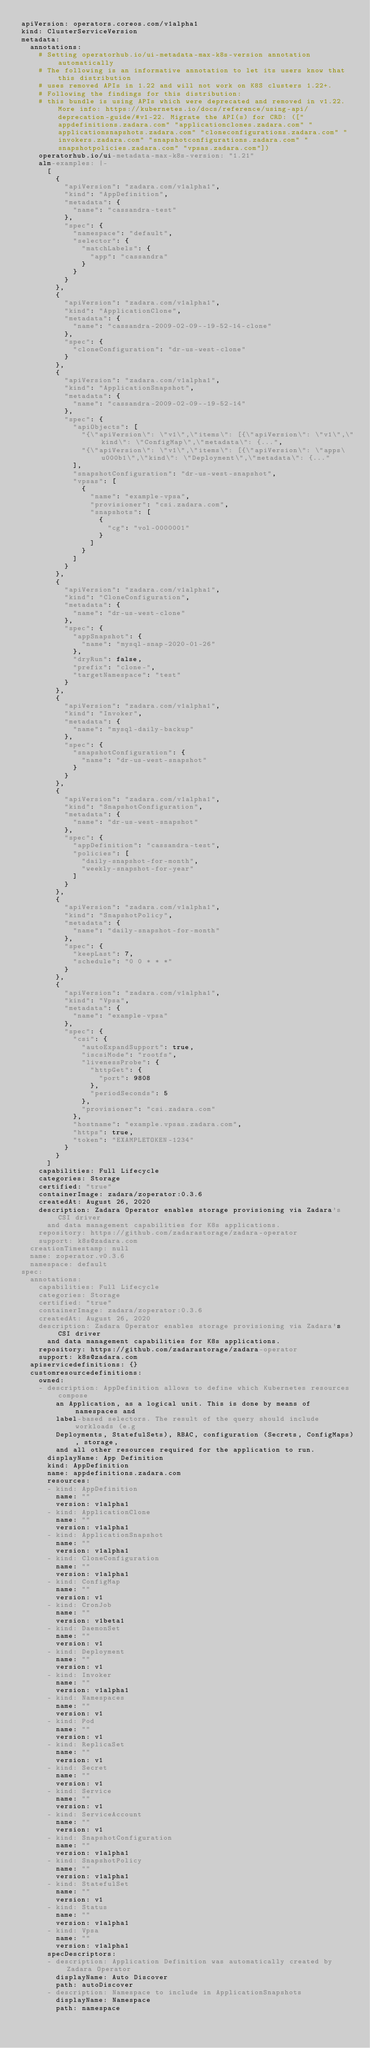<code> <loc_0><loc_0><loc_500><loc_500><_YAML_>apiVersion: operators.coreos.com/v1alpha1
kind: ClusterServiceVersion
metadata:
  annotations:
    # Setting operatorhub.io/ui-metadata-max-k8s-version annotation automatically
    # The following is an informative annotation to let its users know that this distribution
    # uses removed APIs in 1.22 and will not work on K8S clusters 1.22+.
    # Following the findings for this distribution:
    # this bundle is using APIs which were deprecated and removed in v1.22. More info: https://kubernetes.io/docs/reference/using-api/deprecation-guide/#v1-22. Migrate the API(s) for CRD: (["appdefinitions.zadara.com" "applicationclones.zadara.com" "applicationsnapshots.zadara.com" "cloneconfigurations.zadara.com" "invokers.zadara.com" "snapshotconfigurations.zadara.com" "snapshotpolicies.zadara.com" "vpsas.zadara.com"])
    operatorhub.io/ui-metadata-max-k8s-version: "1.21"
    alm-examples: |-
      [
        {
          "apiVersion": "zadara.com/v1alpha1",
          "kind": "AppDefinition",
          "metadata": {
            "name": "cassandra-test"
          },
          "spec": {
            "namespace": "default",
            "selector": {
              "matchLabels": {
                "app": "cassandra"
              }
            }
          }
        },
        {
          "apiVersion": "zadara.com/v1alpha1",
          "kind": "ApplicationClone",
          "metadata": {
            "name": "cassandra-2009-02-09--19-52-14-clone"
          },
          "spec": {
            "cloneConfiguration": "dr-us-west-clone"
          }
        },
        {
          "apiVersion": "zadara.com/v1alpha1",
          "kind": "ApplicationSnapshot",
          "metadata": {
            "name": "cassandra-2009-02-09--19-52-14"
          },
          "spec": {
            "apiObjects": [
              "{\"apiVersion\": \"v1\",\"items\": [{\"apiVersion\": \"v1\",\"kind\": \"ConfigMap\",\"metadata\": {...",
              "{\"apiVersion\": \"v1\",\"items\": [{\"apiVersion\": \"apps\u000b1\",\"kind\": \"Deployment\",\"metadata\": {..."
            ],
            "snapshotConfiguration": "dr-us-west-snapshot",
            "vpsas": [
              {
                "name": "example-vpsa",
                "provisioner": "csi.zadara.com",
                "snapshots": [
                  {
                    "cg": "vol-0000001"
                  }
                ]
              }
            ]
          }
        },
        {
          "apiVersion": "zadara.com/v1alpha1",
          "kind": "CloneConfiguration",
          "metadata": {
            "name": "dr-us-west-clone"
          },
          "spec": {
            "appSnapshot": {
              "name": "mysql-snap-2020-01-26"
            },
            "dryRun": false,
            "prefix": "clone-",
            "targetNamespace": "test"
          }
        },
        {
          "apiVersion": "zadara.com/v1alpha1",
          "kind": "Invoker",
          "metadata": {
            "name": "mysql-daily-backup"
          },
          "spec": {
            "snapshotConfiguration": {
              "name": "dr-us-west-snapshot"
            }
          }
        },
        {
          "apiVersion": "zadara.com/v1alpha1",
          "kind": "SnapshotConfiguration",
          "metadata": {
            "name": "dr-us-west-snapshot"
          },
          "spec": {
            "appDefinition": "cassandra-test",
            "policies": [
              "daily-snapshot-for-month",
              "weekly-snapshot-for-year"
            ]
          }
        },
        {
          "apiVersion": "zadara.com/v1alpha1",
          "kind": "SnapshotPolicy",
          "metadata": {
            "name": "daily-snapshot-for-month"
          },
          "spec": {
            "keepLast": 7,
            "schedule": "0 0 * * *"
          }
        },
        {
          "apiVersion": "zadara.com/v1alpha1",
          "kind": "Vpsa",
          "metadata": {
            "name": "example-vpsa"
          },
          "spec": {
            "csi": {
              "autoExpandSupport": true,
              "iscsiMode": "rootfs",
              "livenessProbe": {
                "httpGet": {
                  "port": 9808
                },
                "periodSeconds": 5
              },
              "provisioner": "csi.zadara.com"
            },
            "hostname": "example.vpsas.zadara.com",
            "https": true,
            "token": "EXAMPLETOKEN-1234"
          }
        }
      ]
    capabilities: Full Lifecycle
    categories: Storage
    certified: "true"
    containerImage: zadara/zoperator:0.3.6
    createdAt: August 26, 2020
    description: Zadara Operator enables storage provisioning via Zadara's CSI driver
      and data management capabilities for K8s applications.
    repository: https://github.com/zadarastorage/zadara-operator
    support: k8s@zadara.com
  creationTimestamp: null
  name: zoperator.v0.3.6
  namespace: default
spec:
  annotations:
    capabilities: Full Lifecycle
    categories: Storage
    certified: "true"
    containerImage: zadara/zoperator:0.3.6
    createdAt: August 26, 2020
    description: Zadara Operator enables storage provisioning via Zadara's CSI driver
      and data management capabilities for K8s applications.
    repository: https://github.com/zadarastorage/zadara-operator
    support: k8s@zadara.com
  apiservicedefinitions: {}
  customresourcedefinitions:
    owned:
    - description: AppDefinition allows to define which Kubernetes resources compose
        an Application, as a logical unit. This is done by means of namespaces and
        label-based selectors. The result of the query should include workloads (e.g
        Deployments, StatefulSets), RBAC, configuration (Secrets, ConfigMaps), storage,
        and all other resources required for the application to run.
      displayName: App Definition
      kind: AppDefinition
      name: appdefinitions.zadara.com
      resources:
      - kind: AppDefinition
        name: ""
        version: v1alpha1
      - kind: ApplicationClone
        name: ""
        version: v1alpha1
      - kind: ApplicationSnapshot
        name: ""
        version: v1alpha1
      - kind: CloneConfiguration
        name: ""
        version: v1alpha1
      - kind: ConfigMap
        name: ""
        version: v1
      - kind: CronJob
        name: ""
        version: v1beta1
      - kind: DaemonSet
        name: ""
        version: v1
      - kind: Deployment
        name: ""
        version: v1
      - kind: Invoker
        name: ""
        version: v1alpha1
      - kind: Namespaces
        name: ""
        version: v1
      - kind: Pod
        name: ""
        version: v1
      - kind: ReplicaSet
        name: ""
        version: v1
      - kind: Secret
        name: ""
        version: v1
      - kind: Service
        name: ""
        version: v1
      - kind: ServiceAccount
        name: ""
        version: v1
      - kind: SnapshotConfiguration
        name: ""
        version: v1alpha1
      - kind: SnapshotPolicy
        name: ""
        version: v1alpha1
      - kind: StatefulSet
        name: ""
        version: v1
      - kind: Status
        name: ""
        version: v1alpha1
      - kind: Vpsa
        name: ""
        version: v1alpha1
      specDescriptors:
      - description: Application Definition was automatically created by Zadara Operator
        displayName: Auto Discover
        path: autoDiscover
      - description: Namespace to include in ApplicationSnapshots
        displayName: Namespace
        path: namespace</code> 